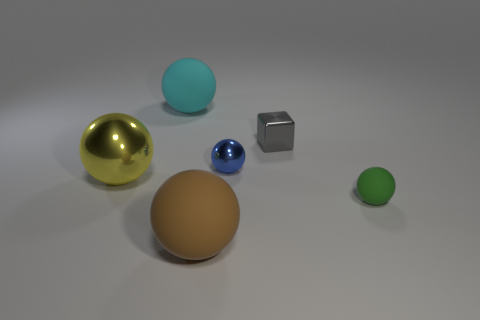There is a thing on the left side of the cyan thing on the left side of the blue object; what is its shape?
Your answer should be very brief. Sphere. Does the object that is in front of the small green rubber sphere have the same material as the green ball that is behind the large brown matte sphere?
Give a very brief answer. Yes. How big is the matte thing that is in front of the small green matte ball?
Offer a terse response. Large. What material is the large yellow thing that is the same shape as the tiny blue object?
Make the answer very short. Metal. What is the shape of the big rubber thing behind the tiny blue shiny sphere?
Offer a very short reply. Sphere. What number of big purple metal objects are the same shape as the cyan thing?
Make the answer very short. 0. Is the number of cyan matte things right of the cyan matte sphere the same as the number of big matte balls that are in front of the tiny gray cube?
Your response must be concise. No. Are there any other tiny objects made of the same material as the yellow object?
Your response must be concise. Yes. Is the blue object made of the same material as the green object?
Provide a succinct answer. No. What number of gray things are large spheres or metallic spheres?
Make the answer very short. 0. 